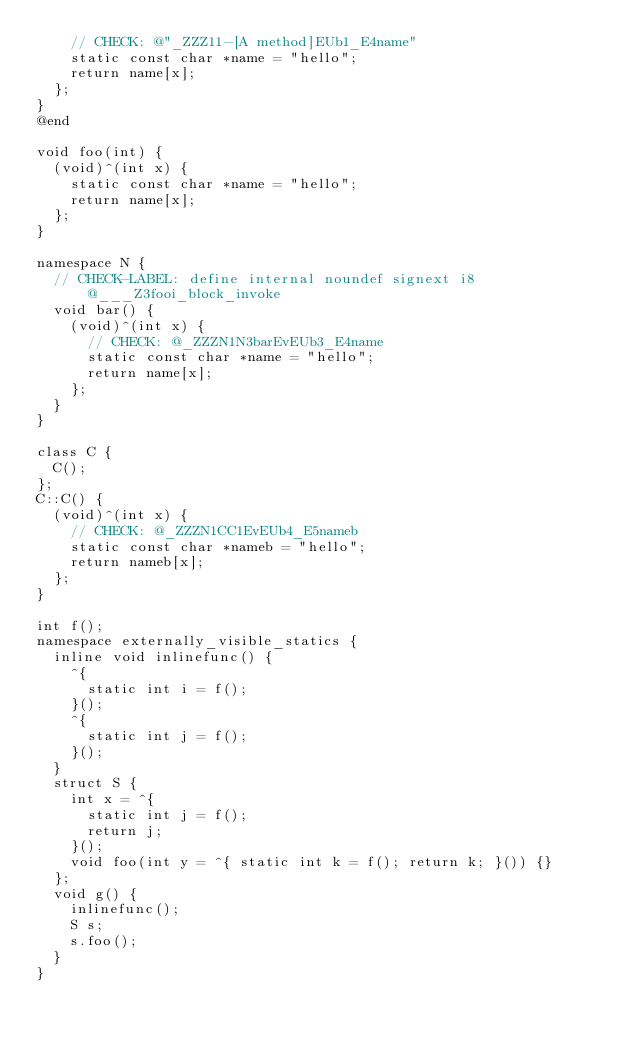<code> <loc_0><loc_0><loc_500><loc_500><_ObjectiveC_>    // CHECK: @"_ZZZ11-[A method]EUb1_E4name"
    static const char *name = "hello";
    return name[x];
  };
}
@end

void foo(int) {
  (void)^(int x) { 
    static const char *name = "hello";
    return name[x];
  };
}

namespace N {
  // CHECK-LABEL: define internal noundef signext i8 @___Z3fooi_block_invoke
  void bar() {
    (void)^(int x) { 
      // CHECK: @_ZZZN1N3barEvEUb3_E4name
      static const char *name = "hello";
      return name[x];
    };
  }
}

class C {
  C();
};
C::C() {
  (void)^(int x) { 
    // CHECK: @_ZZZN1CC1EvEUb4_E5nameb
    static const char *nameb = "hello";
    return nameb[x];
  };
}

int f();
namespace externally_visible_statics {
  inline void inlinefunc() {
    ^{
      static int i = f();
    }();
    ^{
      static int j = f();
    }();
  }
  struct S {
    int x = ^{
      static int j = f();
      return j;
    }();
    void foo(int y = ^{ static int k = f(); return k; }()) {}
  };
  void g() {
    inlinefunc();
    S s;
    s.foo();
  }
}
</code> 